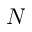Convert formula to latex. <formula><loc_0><loc_0><loc_500><loc_500>N</formula> 